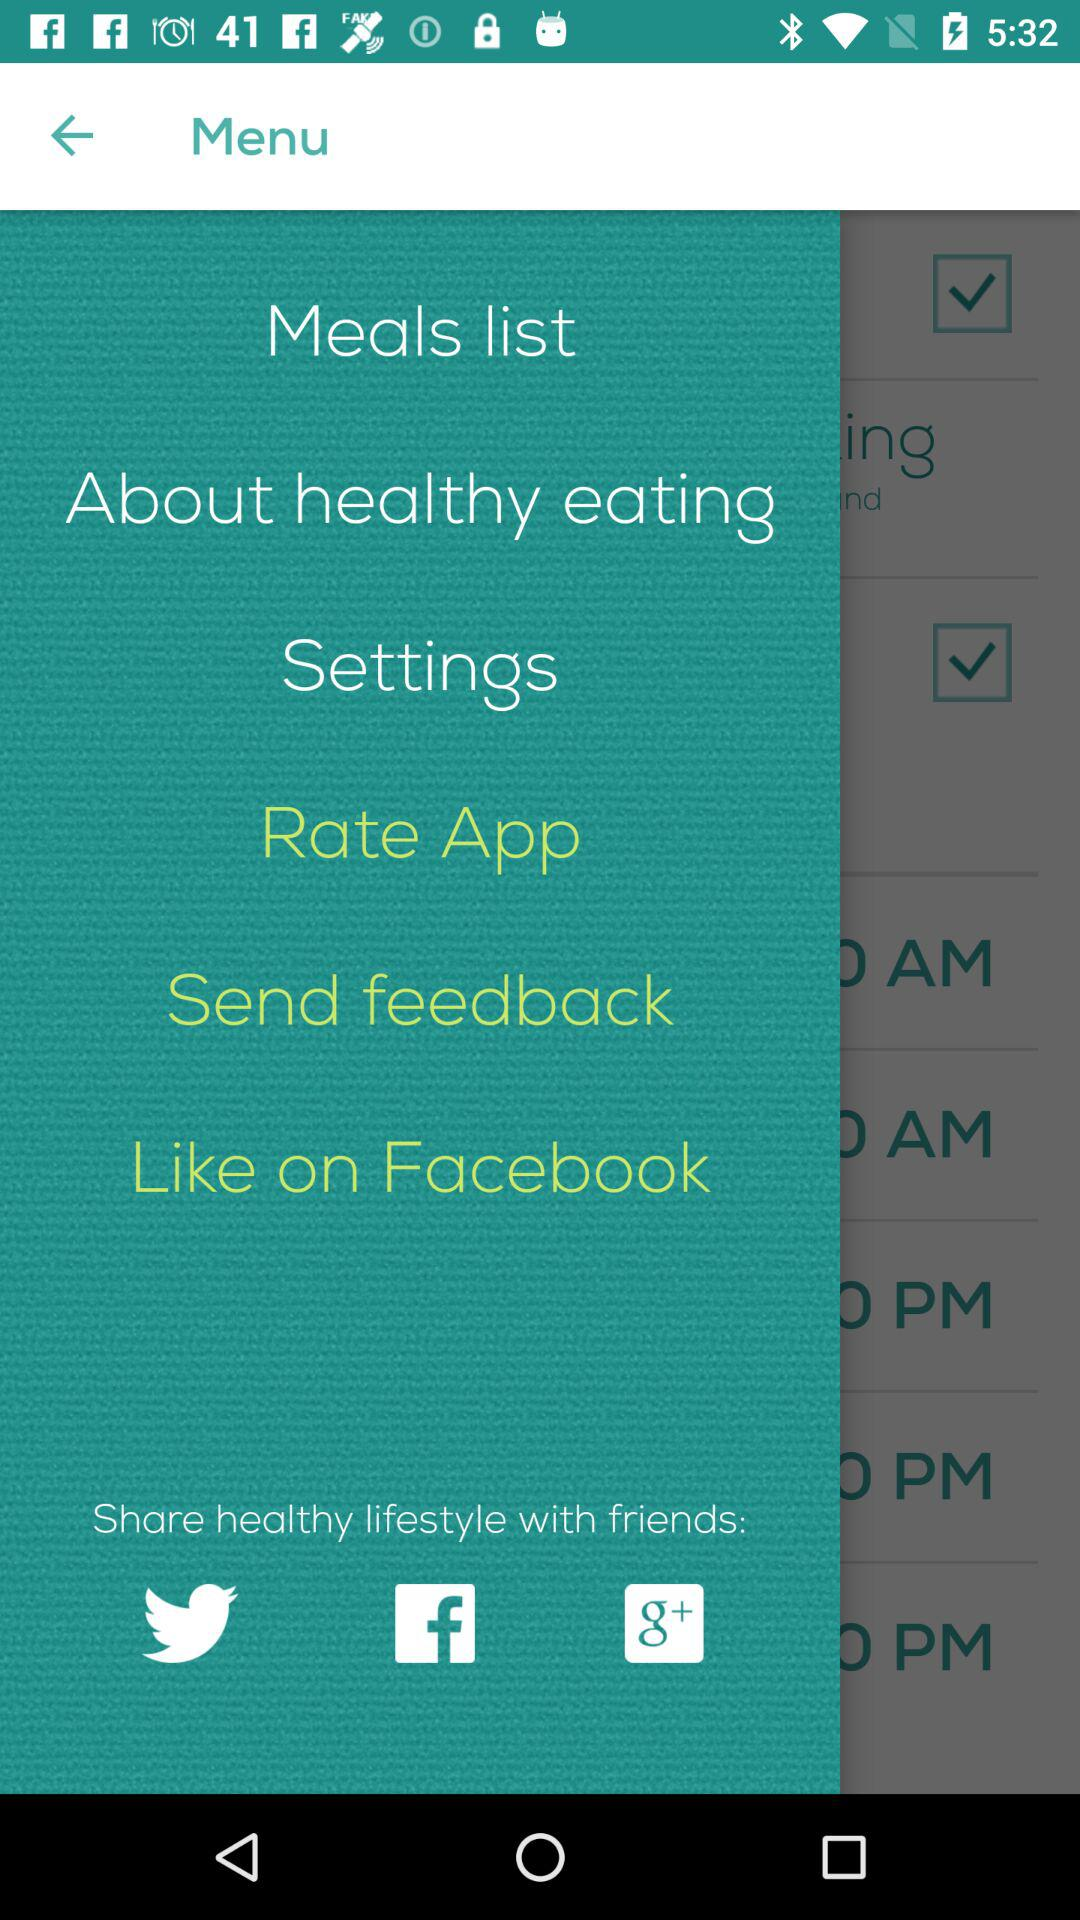What are the sharing options? The sharing options are "Twitter", "Facebook", and "Google+". 